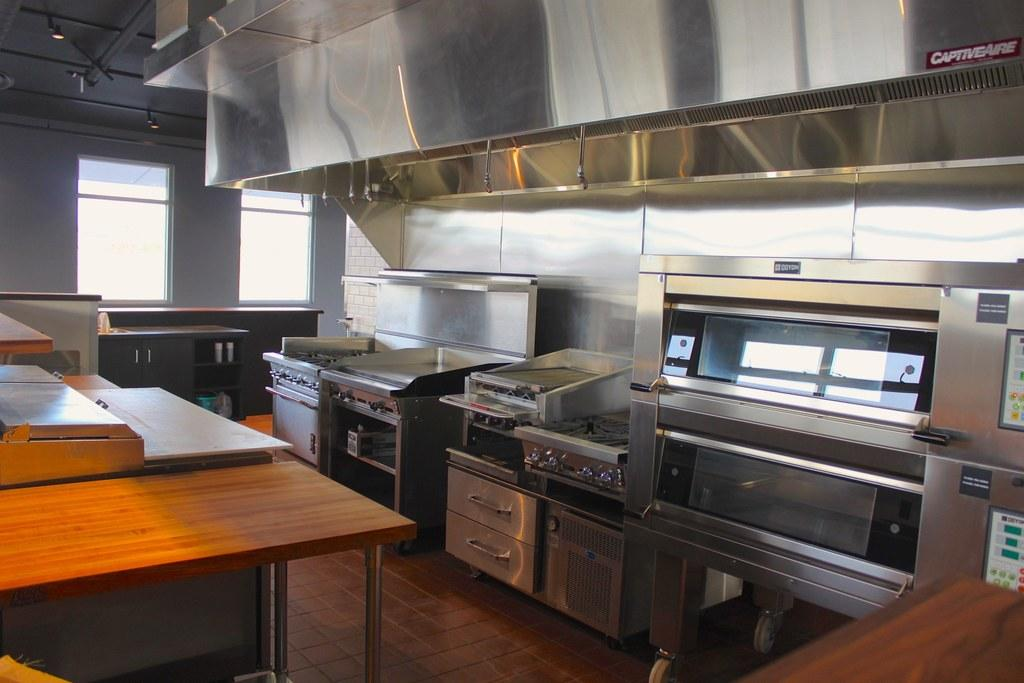What type of objects can be seen on the floor in the image? There are machines on the floor in the image. What other objects can be found in the image besides the machines? There is a table in the image. What type of coat is the cook wearing in the image? There is no cook or coat present in the image; it only features machines on the floor and a table. What type of hospital is depicted in the image? There is no hospital depicted in the image; it only features machines on the floor and a table. 